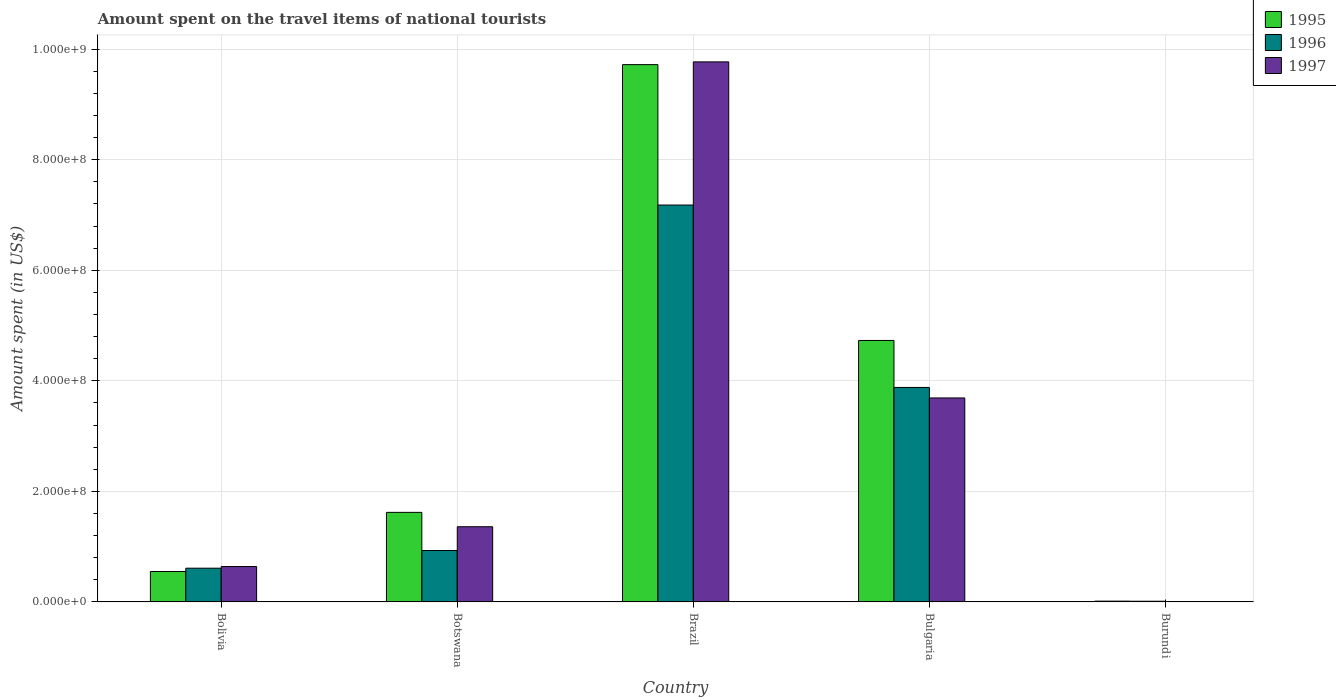How many different coloured bars are there?
Keep it short and to the point. 3. Are the number of bars per tick equal to the number of legend labels?
Your response must be concise. Yes. Are the number of bars on each tick of the X-axis equal?
Offer a terse response. Yes. How many bars are there on the 5th tick from the left?
Offer a very short reply. 3. How many bars are there on the 5th tick from the right?
Make the answer very short. 3. What is the amount spent on the travel items of national tourists in 1996 in Bulgaria?
Ensure brevity in your answer.  3.88e+08. Across all countries, what is the maximum amount spent on the travel items of national tourists in 1995?
Provide a succinct answer. 9.72e+08. In which country was the amount spent on the travel items of national tourists in 1995 maximum?
Give a very brief answer. Brazil. In which country was the amount spent on the travel items of national tourists in 1995 minimum?
Keep it short and to the point. Burundi. What is the total amount spent on the travel items of national tourists in 1997 in the graph?
Offer a terse response. 1.55e+09. What is the difference between the amount spent on the travel items of national tourists in 1995 in Bolivia and that in Bulgaria?
Your answer should be very brief. -4.18e+08. What is the difference between the amount spent on the travel items of national tourists in 1995 in Brazil and the amount spent on the travel items of national tourists in 1997 in Bolivia?
Offer a terse response. 9.08e+08. What is the average amount spent on the travel items of national tourists in 1997 per country?
Make the answer very short. 3.09e+08. What is the difference between the amount spent on the travel items of national tourists of/in 1997 and amount spent on the travel items of national tourists of/in 1995 in Botswana?
Your answer should be very brief. -2.60e+07. What is the ratio of the amount spent on the travel items of national tourists in 1996 in Brazil to that in Bulgaria?
Keep it short and to the point. 1.85. Is the difference between the amount spent on the travel items of national tourists in 1997 in Brazil and Burundi greater than the difference between the amount spent on the travel items of national tourists in 1995 in Brazil and Burundi?
Your answer should be compact. Yes. What is the difference between the highest and the second highest amount spent on the travel items of national tourists in 1995?
Keep it short and to the point. 4.99e+08. What is the difference between the highest and the lowest amount spent on the travel items of national tourists in 1997?
Your response must be concise. 9.76e+08. In how many countries, is the amount spent on the travel items of national tourists in 1997 greater than the average amount spent on the travel items of national tourists in 1997 taken over all countries?
Your response must be concise. 2. Is the sum of the amount spent on the travel items of national tourists in 1997 in Brazil and Burundi greater than the maximum amount spent on the travel items of national tourists in 1995 across all countries?
Offer a very short reply. Yes. How many bars are there?
Ensure brevity in your answer.  15. Are all the bars in the graph horizontal?
Ensure brevity in your answer.  No. How many countries are there in the graph?
Make the answer very short. 5. What is the difference between two consecutive major ticks on the Y-axis?
Offer a very short reply. 2.00e+08. Does the graph contain any zero values?
Offer a very short reply. No. Does the graph contain grids?
Keep it short and to the point. Yes. Where does the legend appear in the graph?
Provide a succinct answer. Top right. What is the title of the graph?
Keep it short and to the point. Amount spent on the travel items of national tourists. What is the label or title of the Y-axis?
Give a very brief answer. Amount spent (in US$). What is the Amount spent (in US$) of 1995 in Bolivia?
Make the answer very short. 5.50e+07. What is the Amount spent (in US$) in 1996 in Bolivia?
Your answer should be compact. 6.10e+07. What is the Amount spent (in US$) of 1997 in Bolivia?
Make the answer very short. 6.40e+07. What is the Amount spent (in US$) of 1995 in Botswana?
Keep it short and to the point. 1.62e+08. What is the Amount spent (in US$) of 1996 in Botswana?
Offer a very short reply. 9.30e+07. What is the Amount spent (in US$) of 1997 in Botswana?
Make the answer very short. 1.36e+08. What is the Amount spent (in US$) in 1995 in Brazil?
Your answer should be very brief. 9.72e+08. What is the Amount spent (in US$) in 1996 in Brazil?
Make the answer very short. 7.18e+08. What is the Amount spent (in US$) in 1997 in Brazil?
Your answer should be very brief. 9.77e+08. What is the Amount spent (in US$) of 1995 in Bulgaria?
Give a very brief answer. 4.73e+08. What is the Amount spent (in US$) in 1996 in Bulgaria?
Ensure brevity in your answer.  3.88e+08. What is the Amount spent (in US$) in 1997 in Bulgaria?
Keep it short and to the point. 3.69e+08. What is the Amount spent (in US$) in 1995 in Burundi?
Provide a succinct answer. 1.40e+06. What is the Amount spent (in US$) in 1996 in Burundi?
Make the answer very short. 1.20e+06. What is the Amount spent (in US$) in 1997 in Burundi?
Give a very brief answer. 6.00e+05. Across all countries, what is the maximum Amount spent (in US$) of 1995?
Give a very brief answer. 9.72e+08. Across all countries, what is the maximum Amount spent (in US$) of 1996?
Your answer should be very brief. 7.18e+08. Across all countries, what is the maximum Amount spent (in US$) of 1997?
Keep it short and to the point. 9.77e+08. Across all countries, what is the minimum Amount spent (in US$) of 1995?
Your answer should be very brief. 1.40e+06. Across all countries, what is the minimum Amount spent (in US$) in 1996?
Provide a short and direct response. 1.20e+06. What is the total Amount spent (in US$) of 1995 in the graph?
Provide a short and direct response. 1.66e+09. What is the total Amount spent (in US$) of 1996 in the graph?
Your response must be concise. 1.26e+09. What is the total Amount spent (in US$) of 1997 in the graph?
Your response must be concise. 1.55e+09. What is the difference between the Amount spent (in US$) in 1995 in Bolivia and that in Botswana?
Offer a terse response. -1.07e+08. What is the difference between the Amount spent (in US$) of 1996 in Bolivia and that in Botswana?
Offer a very short reply. -3.20e+07. What is the difference between the Amount spent (in US$) of 1997 in Bolivia and that in Botswana?
Your answer should be compact. -7.20e+07. What is the difference between the Amount spent (in US$) in 1995 in Bolivia and that in Brazil?
Provide a succinct answer. -9.17e+08. What is the difference between the Amount spent (in US$) in 1996 in Bolivia and that in Brazil?
Offer a very short reply. -6.57e+08. What is the difference between the Amount spent (in US$) of 1997 in Bolivia and that in Brazil?
Your answer should be compact. -9.13e+08. What is the difference between the Amount spent (in US$) of 1995 in Bolivia and that in Bulgaria?
Ensure brevity in your answer.  -4.18e+08. What is the difference between the Amount spent (in US$) of 1996 in Bolivia and that in Bulgaria?
Provide a short and direct response. -3.27e+08. What is the difference between the Amount spent (in US$) in 1997 in Bolivia and that in Bulgaria?
Ensure brevity in your answer.  -3.05e+08. What is the difference between the Amount spent (in US$) in 1995 in Bolivia and that in Burundi?
Your response must be concise. 5.36e+07. What is the difference between the Amount spent (in US$) of 1996 in Bolivia and that in Burundi?
Make the answer very short. 5.98e+07. What is the difference between the Amount spent (in US$) of 1997 in Bolivia and that in Burundi?
Ensure brevity in your answer.  6.34e+07. What is the difference between the Amount spent (in US$) in 1995 in Botswana and that in Brazil?
Keep it short and to the point. -8.10e+08. What is the difference between the Amount spent (in US$) in 1996 in Botswana and that in Brazil?
Your response must be concise. -6.25e+08. What is the difference between the Amount spent (in US$) in 1997 in Botswana and that in Brazil?
Your response must be concise. -8.41e+08. What is the difference between the Amount spent (in US$) in 1995 in Botswana and that in Bulgaria?
Your answer should be compact. -3.11e+08. What is the difference between the Amount spent (in US$) in 1996 in Botswana and that in Bulgaria?
Offer a terse response. -2.95e+08. What is the difference between the Amount spent (in US$) in 1997 in Botswana and that in Bulgaria?
Provide a short and direct response. -2.33e+08. What is the difference between the Amount spent (in US$) in 1995 in Botswana and that in Burundi?
Give a very brief answer. 1.61e+08. What is the difference between the Amount spent (in US$) in 1996 in Botswana and that in Burundi?
Your response must be concise. 9.18e+07. What is the difference between the Amount spent (in US$) of 1997 in Botswana and that in Burundi?
Give a very brief answer. 1.35e+08. What is the difference between the Amount spent (in US$) in 1995 in Brazil and that in Bulgaria?
Make the answer very short. 4.99e+08. What is the difference between the Amount spent (in US$) of 1996 in Brazil and that in Bulgaria?
Make the answer very short. 3.30e+08. What is the difference between the Amount spent (in US$) in 1997 in Brazil and that in Bulgaria?
Give a very brief answer. 6.08e+08. What is the difference between the Amount spent (in US$) of 1995 in Brazil and that in Burundi?
Offer a very short reply. 9.71e+08. What is the difference between the Amount spent (in US$) in 1996 in Brazil and that in Burundi?
Offer a terse response. 7.17e+08. What is the difference between the Amount spent (in US$) of 1997 in Brazil and that in Burundi?
Offer a terse response. 9.76e+08. What is the difference between the Amount spent (in US$) of 1995 in Bulgaria and that in Burundi?
Provide a succinct answer. 4.72e+08. What is the difference between the Amount spent (in US$) in 1996 in Bulgaria and that in Burundi?
Make the answer very short. 3.87e+08. What is the difference between the Amount spent (in US$) of 1997 in Bulgaria and that in Burundi?
Ensure brevity in your answer.  3.68e+08. What is the difference between the Amount spent (in US$) in 1995 in Bolivia and the Amount spent (in US$) in 1996 in Botswana?
Make the answer very short. -3.80e+07. What is the difference between the Amount spent (in US$) of 1995 in Bolivia and the Amount spent (in US$) of 1997 in Botswana?
Offer a very short reply. -8.10e+07. What is the difference between the Amount spent (in US$) in 1996 in Bolivia and the Amount spent (in US$) in 1997 in Botswana?
Your answer should be very brief. -7.50e+07. What is the difference between the Amount spent (in US$) in 1995 in Bolivia and the Amount spent (in US$) in 1996 in Brazil?
Give a very brief answer. -6.63e+08. What is the difference between the Amount spent (in US$) in 1995 in Bolivia and the Amount spent (in US$) in 1997 in Brazil?
Your answer should be compact. -9.22e+08. What is the difference between the Amount spent (in US$) in 1996 in Bolivia and the Amount spent (in US$) in 1997 in Brazil?
Provide a succinct answer. -9.16e+08. What is the difference between the Amount spent (in US$) of 1995 in Bolivia and the Amount spent (in US$) of 1996 in Bulgaria?
Provide a short and direct response. -3.33e+08. What is the difference between the Amount spent (in US$) of 1995 in Bolivia and the Amount spent (in US$) of 1997 in Bulgaria?
Provide a succinct answer. -3.14e+08. What is the difference between the Amount spent (in US$) of 1996 in Bolivia and the Amount spent (in US$) of 1997 in Bulgaria?
Your answer should be compact. -3.08e+08. What is the difference between the Amount spent (in US$) in 1995 in Bolivia and the Amount spent (in US$) in 1996 in Burundi?
Keep it short and to the point. 5.38e+07. What is the difference between the Amount spent (in US$) in 1995 in Bolivia and the Amount spent (in US$) in 1997 in Burundi?
Give a very brief answer. 5.44e+07. What is the difference between the Amount spent (in US$) of 1996 in Bolivia and the Amount spent (in US$) of 1997 in Burundi?
Provide a short and direct response. 6.04e+07. What is the difference between the Amount spent (in US$) in 1995 in Botswana and the Amount spent (in US$) in 1996 in Brazil?
Give a very brief answer. -5.56e+08. What is the difference between the Amount spent (in US$) in 1995 in Botswana and the Amount spent (in US$) in 1997 in Brazil?
Offer a very short reply. -8.15e+08. What is the difference between the Amount spent (in US$) in 1996 in Botswana and the Amount spent (in US$) in 1997 in Brazil?
Provide a short and direct response. -8.84e+08. What is the difference between the Amount spent (in US$) of 1995 in Botswana and the Amount spent (in US$) of 1996 in Bulgaria?
Give a very brief answer. -2.26e+08. What is the difference between the Amount spent (in US$) of 1995 in Botswana and the Amount spent (in US$) of 1997 in Bulgaria?
Ensure brevity in your answer.  -2.07e+08. What is the difference between the Amount spent (in US$) in 1996 in Botswana and the Amount spent (in US$) in 1997 in Bulgaria?
Keep it short and to the point. -2.76e+08. What is the difference between the Amount spent (in US$) in 1995 in Botswana and the Amount spent (in US$) in 1996 in Burundi?
Keep it short and to the point. 1.61e+08. What is the difference between the Amount spent (in US$) in 1995 in Botswana and the Amount spent (in US$) in 1997 in Burundi?
Your answer should be compact. 1.61e+08. What is the difference between the Amount spent (in US$) of 1996 in Botswana and the Amount spent (in US$) of 1997 in Burundi?
Keep it short and to the point. 9.24e+07. What is the difference between the Amount spent (in US$) in 1995 in Brazil and the Amount spent (in US$) in 1996 in Bulgaria?
Provide a succinct answer. 5.84e+08. What is the difference between the Amount spent (in US$) in 1995 in Brazil and the Amount spent (in US$) in 1997 in Bulgaria?
Your answer should be very brief. 6.03e+08. What is the difference between the Amount spent (in US$) of 1996 in Brazil and the Amount spent (in US$) of 1997 in Bulgaria?
Your answer should be compact. 3.49e+08. What is the difference between the Amount spent (in US$) of 1995 in Brazil and the Amount spent (in US$) of 1996 in Burundi?
Make the answer very short. 9.71e+08. What is the difference between the Amount spent (in US$) in 1995 in Brazil and the Amount spent (in US$) in 1997 in Burundi?
Your answer should be compact. 9.71e+08. What is the difference between the Amount spent (in US$) in 1996 in Brazil and the Amount spent (in US$) in 1997 in Burundi?
Your answer should be very brief. 7.17e+08. What is the difference between the Amount spent (in US$) in 1995 in Bulgaria and the Amount spent (in US$) in 1996 in Burundi?
Make the answer very short. 4.72e+08. What is the difference between the Amount spent (in US$) in 1995 in Bulgaria and the Amount spent (in US$) in 1997 in Burundi?
Make the answer very short. 4.72e+08. What is the difference between the Amount spent (in US$) in 1996 in Bulgaria and the Amount spent (in US$) in 1997 in Burundi?
Provide a succinct answer. 3.87e+08. What is the average Amount spent (in US$) of 1995 per country?
Make the answer very short. 3.33e+08. What is the average Amount spent (in US$) of 1996 per country?
Offer a very short reply. 2.52e+08. What is the average Amount spent (in US$) in 1997 per country?
Make the answer very short. 3.09e+08. What is the difference between the Amount spent (in US$) in 1995 and Amount spent (in US$) in 1996 in Bolivia?
Ensure brevity in your answer.  -6.00e+06. What is the difference between the Amount spent (in US$) in 1995 and Amount spent (in US$) in 1997 in Bolivia?
Provide a short and direct response. -9.00e+06. What is the difference between the Amount spent (in US$) of 1995 and Amount spent (in US$) of 1996 in Botswana?
Your response must be concise. 6.90e+07. What is the difference between the Amount spent (in US$) of 1995 and Amount spent (in US$) of 1997 in Botswana?
Provide a short and direct response. 2.60e+07. What is the difference between the Amount spent (in US$) of 1996 and Amount spent (in US$) of 1997 in Botswana?
Make the answer very short. -4.30e+07. What is the difference between the Amount spent (in US$) in 1995 and Amount spent (in US$) in 1996 in Brazil?
Your answer should be very brief. 2.54e+08. What is the difference between the Amount spent (in US$) of 1995 and Amount spent (in US$) of 1997 in Brazil?
Ensure brevity in your answer.  -5.00e+06. What is the difference between the Amount spent (in US$) in 1996 and Amount spent (in US$) in 1997 in Brazil?
Ensure brevity in your answer.  -2.59e+08. What is the difference between the Amount spent (in US$) of 1995 and Amount spent (in US$) of 1996 in Bulgaria?
Give a very brief answer. 8.50e+07. What is the difference between the Amount spent (in US$) of 1995 and Amount spent (in US$) of 1997 in Bulgaria?
Provide a succinct answer. 1.04e+08. What is the difference between the Amount spent (in US$) in 1996 and Amount spent (in US$) in 1997 in Bulgaria?
Your answer should be compact. 1.90e+07. What is the difference between the Amount spent (in US$) in 1995 and Amount spent (in US$) in 1996 in Burundi?
Make the answer very short. 2.00e+05. What is the ratio of the Amount spent (in US$) of 1995 in Bolivia to that in Botswana?
Offer a very short reply. 0.34. What is the ratio of the Amount spent (in US$) of 1996 in Bolivia to that in Botswana?
Your answer should be very brief. 0.66. What is the ratio of the Amount spent (in US$) of 1997 in Bolivia to that in Botswana?
Give a very brief answer. 0.47. What is the ratio of the Amount spent (in US$) in 1995 in Bolivia to that in Brazil?
Your response must be concise. 0.06. What is the ratio of the Amount spent (in US$) of 1996 in Bolivia to that in Brazil?
Your response must be concise. 0.09. What is the ratio of the Amount spent (in US$) of 1997 in Bolivia to that in Brazil?
Keep it short and to the point. 0.07. What is the ratio of the Amount spent (in US$) in 1995 in Bolivia to that in Bulgaria?
Provide a short and direct response. 0.12. What is the ratio of the Amount spent (in US$) of 1996 in Bolivia to that in Bulgaria?
Ensure brevity in your answer.  0.16. What is the ratio of the Amount spent (in US$) in 1997 in Bolivia to that in Bulgaria?
Your answer should be very brief. 0.17. What is the ratio of the Amount spent (in US$) of 1995 in Bolivia to that in Burundi?
Keep it short and to the point. 39.29. What is the ratio of the Amount spent (in US$) in 1996 in Bolivia to that in Burundi?
Make the answer very short. 50.83. What is the ratio of the Amount spent (in US$) in 1997 in Bolivia to that in Burundi?
Offer a very short reply. 106.67. What is the ratio of the Amount spent (in US$) of 1995 in Botswana to that in Brazil?
Provide a succinct answer. 0.17. What is the ratio of the Amount spent (in US$) in 1996 in Botswana to that in Brazil?
Keep it short and to the point. 0.13. What is the ratio of the Amount spent (in US$) in 1997 in Botswana to that in Brazil?
Provide a succinct answer. 0.14. What is the ratio of the Amount spent (in US$) of 1995 in Botswana to that in Bulgaria?
Keep it short and to the point. 0.34. What is the ratio of the Amount spent (in US$) of 1996 in Botswana to that in Bulgaria?
Provide a short and direct response. 0.24. What is the ratio of the Amount spent (in US$) of 1997 in Botswana to that in Bulgaria?
Ensure brevity in your answer.  0.37. What is the ratio of the Amount spent (in US$) of 1995 in Botswana to that in Burundi?
Your answer should be compact. 115.71. What is the ratio of the Amount spent (in US$) of 1996 in Botswana to that in Burundi?
Keep it short and to the point. 77.5. What is the ratio of the Amount spent (in US$) in 1997 in Botswana to that in Burundi?
Offer a very short reply. 226.67. What is the ratio of the Amount spent (in US$) of 1995 in Brazil to that in Bulgaria?
Provide a short and direct response. 2.06. What is the ratio of the Amount spent (in US$) in 1996 in Brazil to that in Bulgaria?
Offer a terse response. 1.85. What is the ratio of the Amount spent (in US$) of 1997 in Brazil to that in Bulgaria?
Make the answer very short. 2.65. What is the ratio of the Amount spent (in US$) of 1995 in Brazil to that in Burundi?
Your answer should be compact. 694.29. What is the ratio of the Amount spent (in US$) in 1996 in Brazil to that in Burundi?
Offer a terse response. 598.33. What is the ratio of the Amount spent (in US$) in 1997 in Brazil to that in Burundi?
Provide a succinct answer. 1628.33. What is the ratio of the Amount spent (in US$) of 1995 in Bulgaria to that in Burundi?
Your response must be concise. 337.86. What is the ratio of the Amount spent (in US$) of 1996 in Bulgaria to that in Burundi?
Provide a short and direct response. 323.33. What is the ratio of the Amount spent (in US$) in 1997 in Bulgaria to that in Burundi?
Your response must be concise. 615. What is the difference between the highest and the second highest Amount spent (in US$) of 1995?
Your answer should be very brief. 4.99e+08. What is the difference between the highest and the second highest Amount spent (in US$) in 1996?
Your answer should be compact. 3.30e+08. What is the difference between the highest and the second highest Amount spent (in US$) of 1997?
Provide a short and direct response. 6.08e+08. What is the difference between the highest and the lowest Amount spent (in US$) in 1995?
Give a very brief answer. 9.71e+08. What is the difference between the highest and the lowest Amount spent (in US$) of 1996?
Keep it short and to the point. 7.17e+08. What is the difference between the highest and the lowest Amount spent (in US$) of 1997?
Your answer should be very brief. 9.76e+08. 